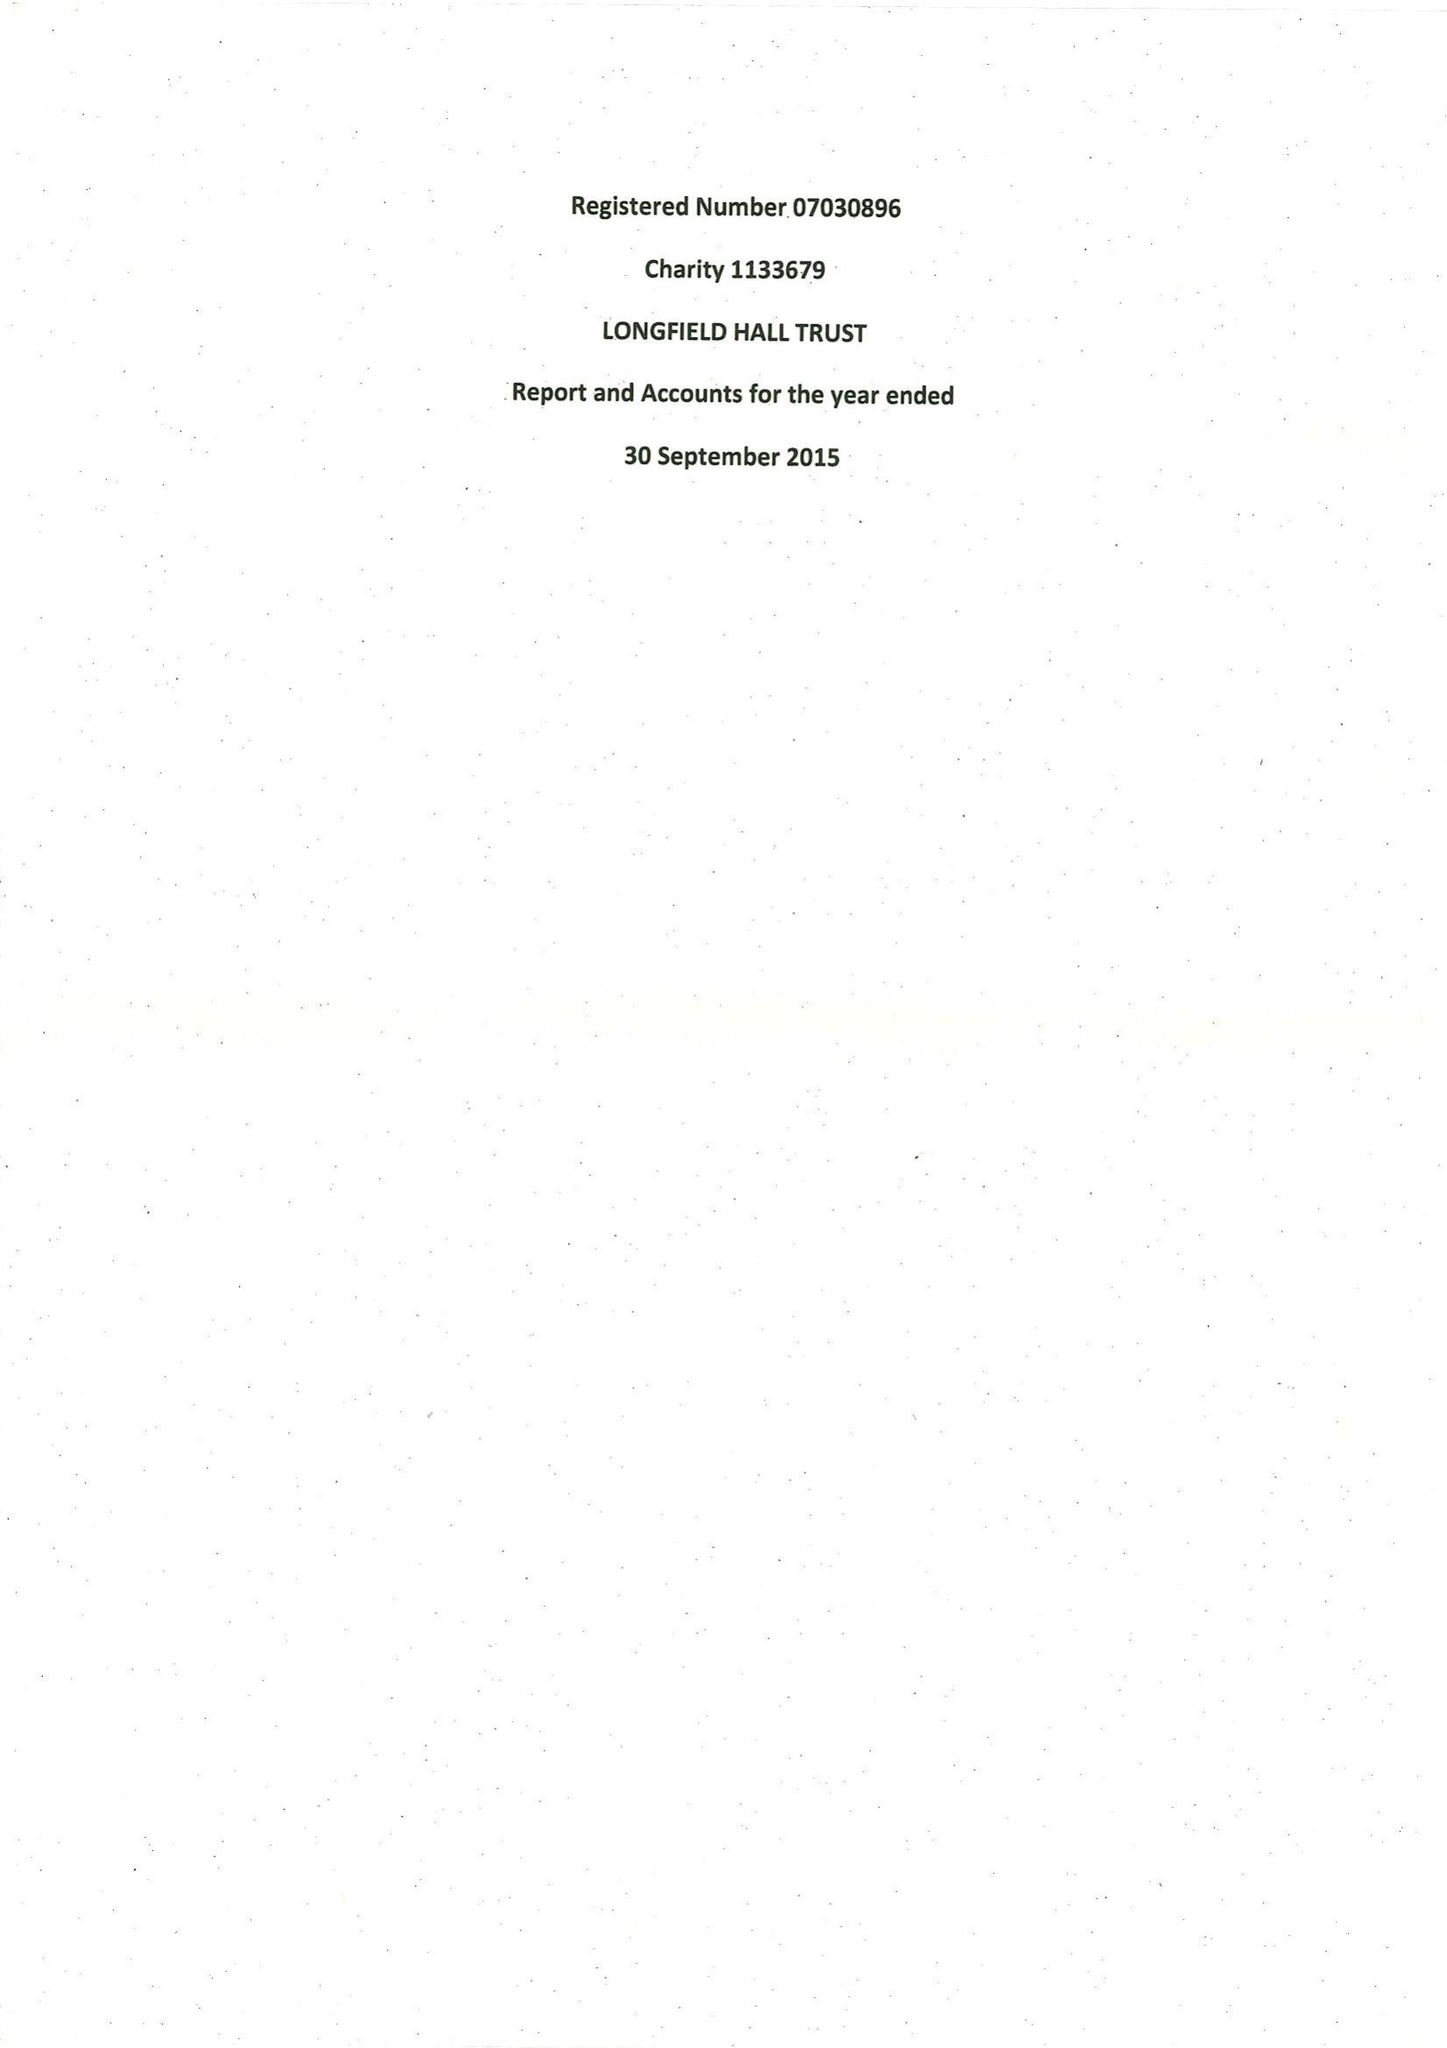What is the value for the address__post_town?
Answer the question using a single word or phrase. LONDON 